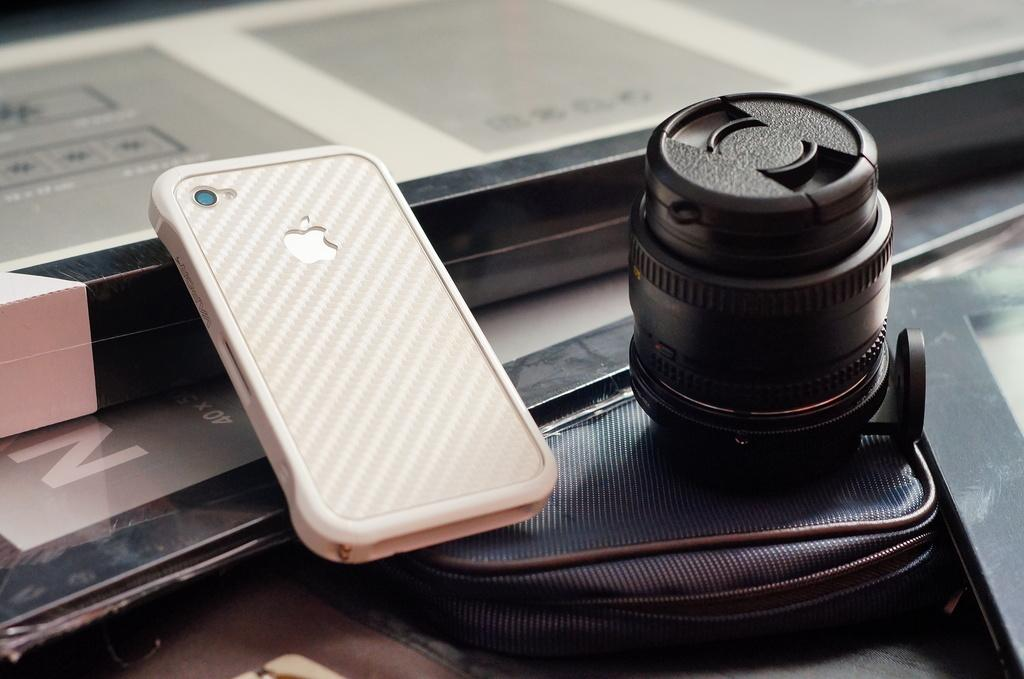What electronic device is visible in the image? There is a phone in the image. What other device can be seen in the image? There is a camera lens in the image. What type of accessory is present in the image? There is a bag in the image. Can you describe the unspecified objects in the image? Unfortunately, the facts provided do not give any details about the unspecified objects in the image. What type of territory is being claimed by the icicle in the image? There is no icicle present in the image, so it cannot be claimed as territory. 